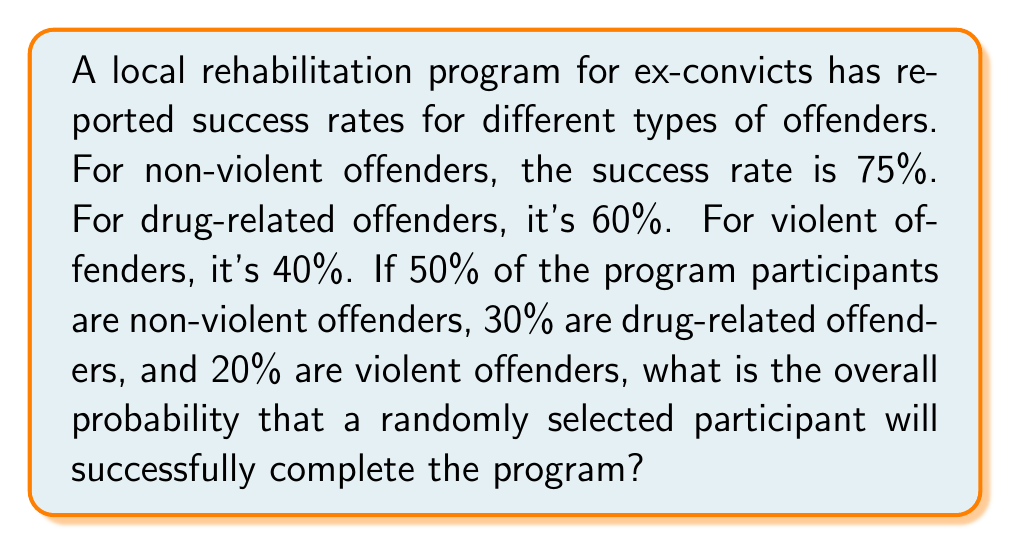What is the answer to this math problem? Let's approach this step-by-step using the law of total probability:

1) Define events:
   A: Successful completion
   N: Non-violent offender
   D: Drug-related offender
   V: Violent offender

2) Given probabilities:
   $P(A|N) = 0.75$
   $P(A|D) = 0.60$
   $P(A|V) = 0.40$
   $P(N) = 0.50$
   $P(D) = 0.30$
   $P(V) = 0.20$

3) Law of Total Probability:
   $P(A) = P(A|N)P(N) + P(A|D)P(D) + P(A|V)P(V)$

4) Substitute the values:
   $P(A) = (0.75)(0.50) + (0.60)(0.30) + (0.40)(0.20)$

5) Calculate:
   $P(A) = 0.375 + 0.18 + 0.08 = 0.635$

Therefore, the overall probability of successful completion is 0.635 or 63.5%.
Answer: 0.635 